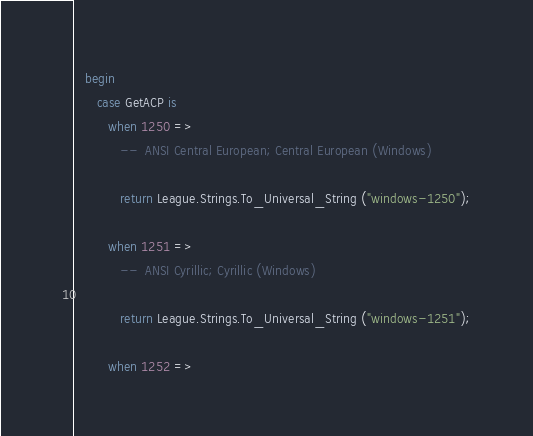Convert code to text. <code><loc_0><loc_0><loc_500><loc_500><_Ada_>   begin
      case GetACP is
         when 1250 =>
            --  ANSI Central European; Central European (Windows)

            return League.Strings.To_Universal_String ("windows-1250");

         when 1251 =>
            --  ANSI Cyrillic; Cyrillic (Windows)

            return League.Strings.To_Universal_String ("windows-1251");

         when 1252 =></code> 